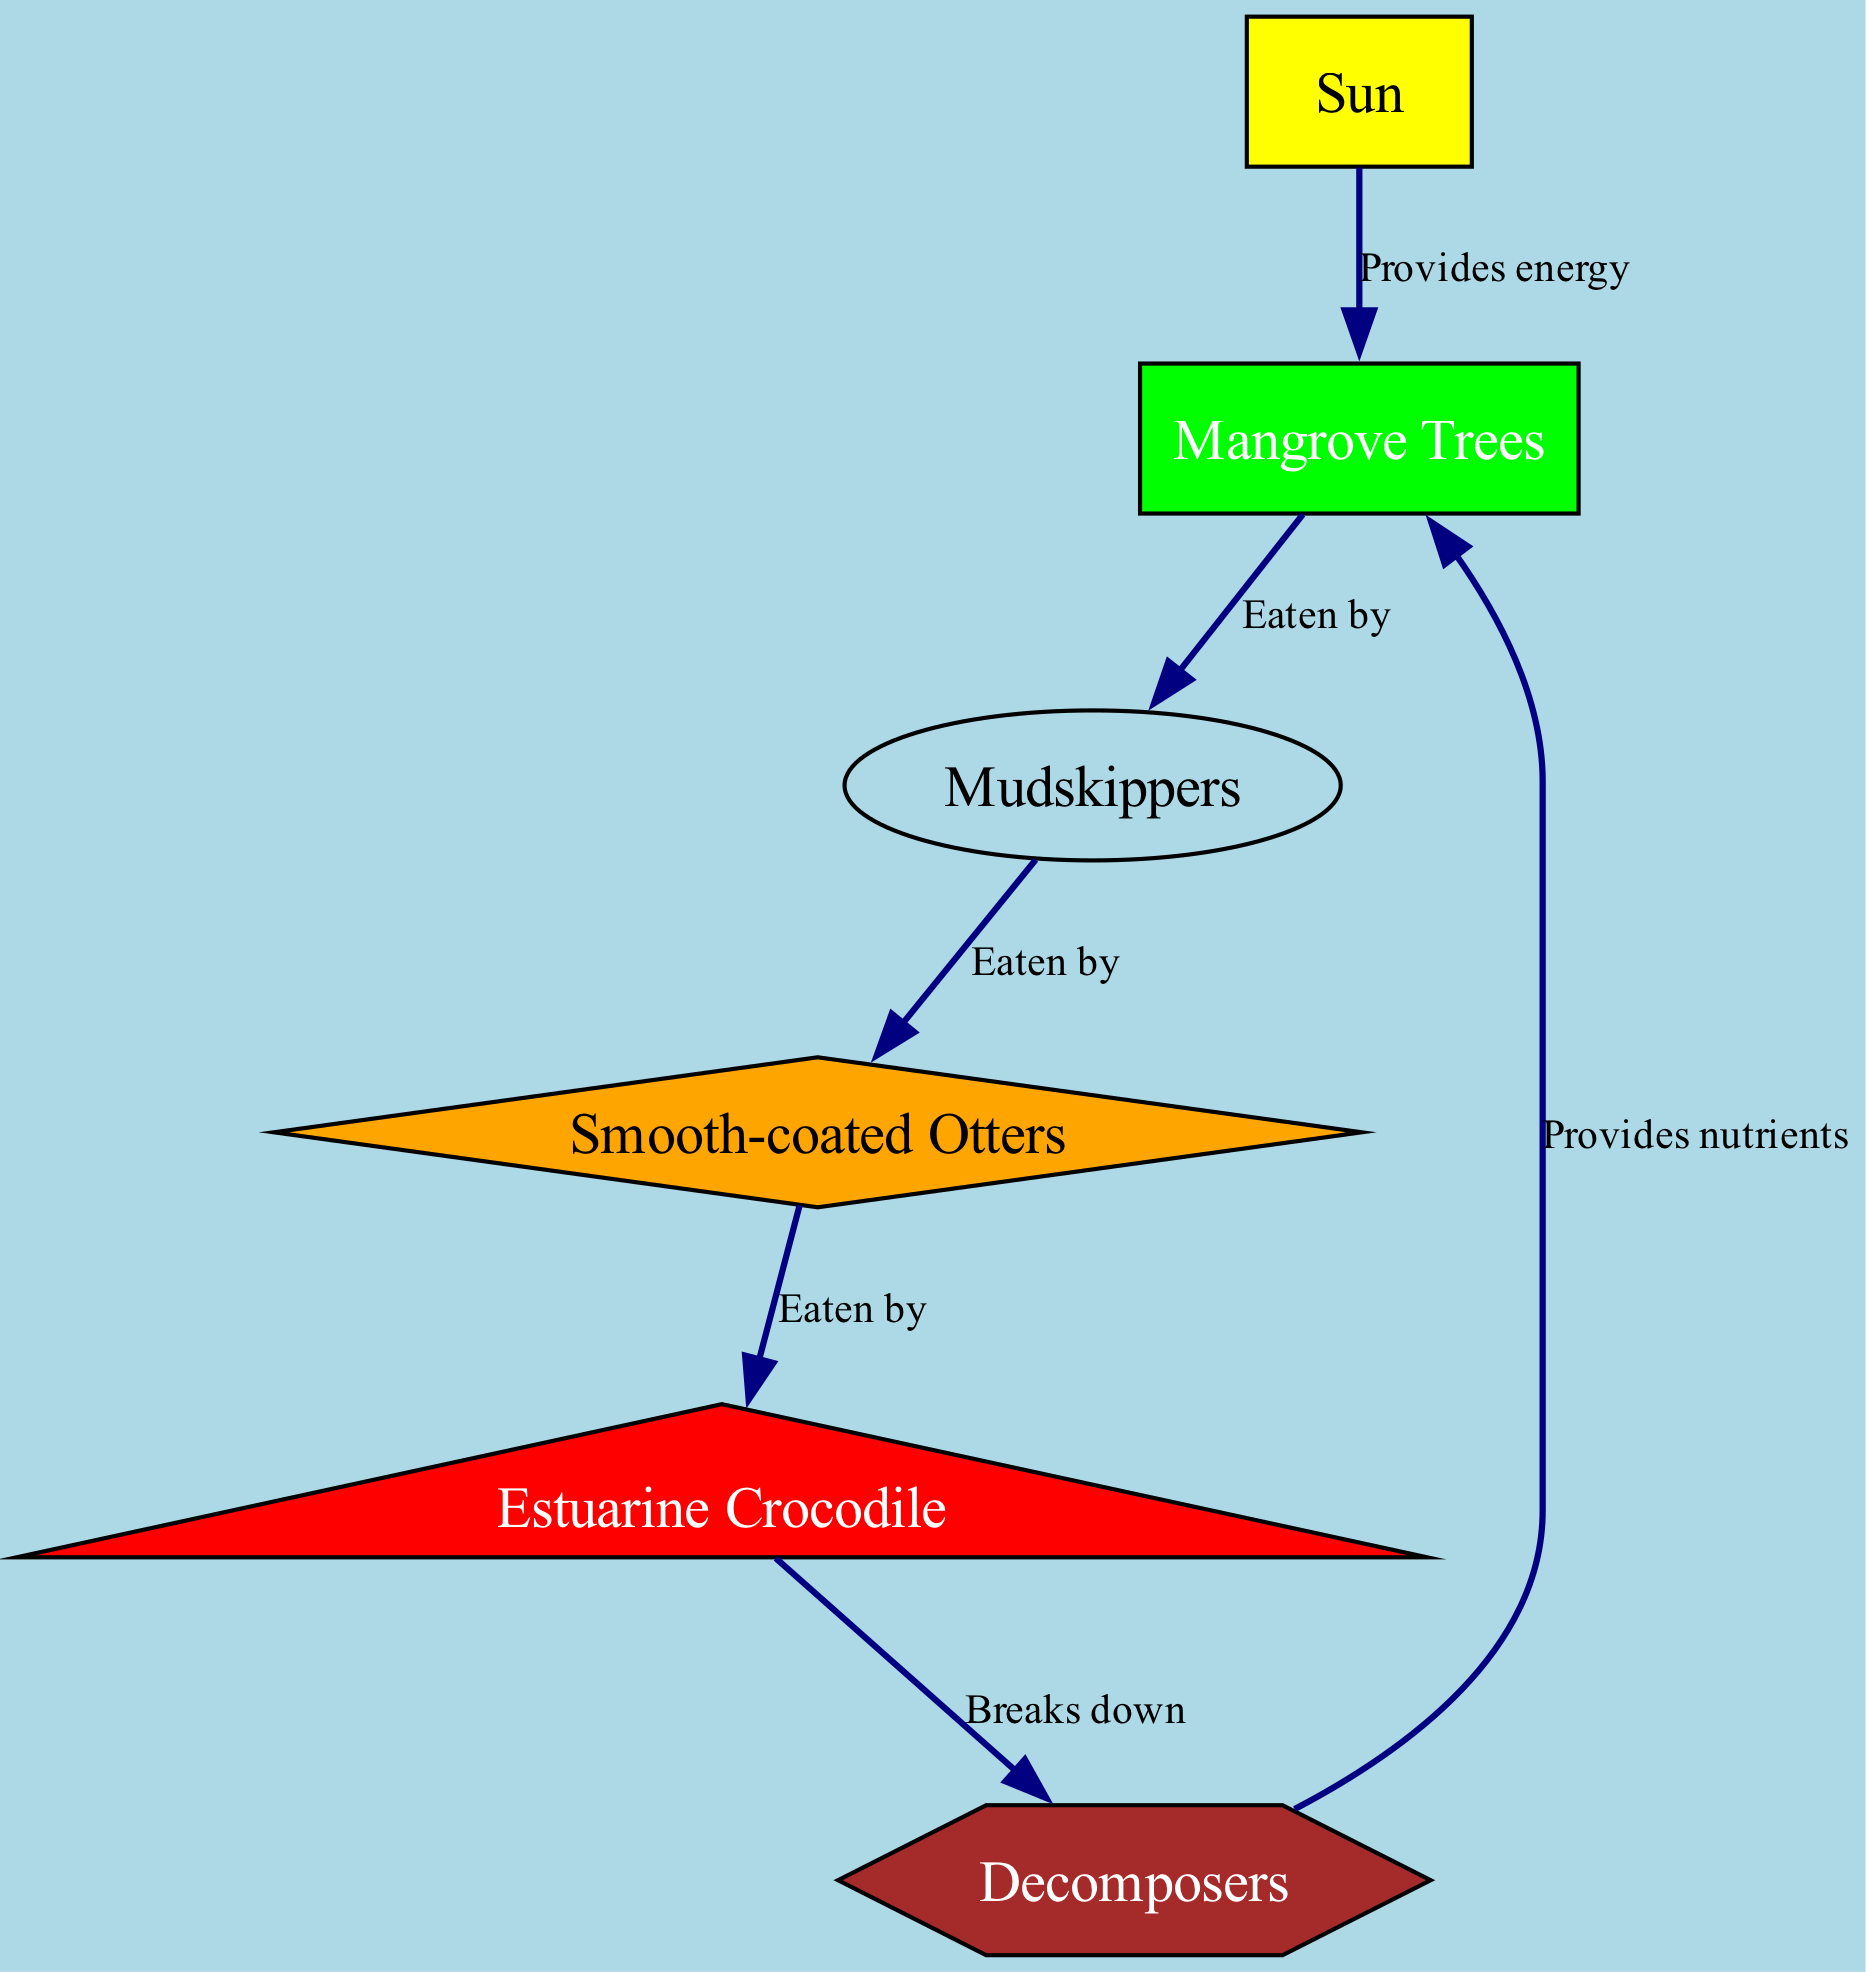What is the primary energy source in this food chain? The first node in the diagram, labeled "Sun," represents the primary energy source that fuels the other organisms in the food chain.
Answer: Sun Which organism is a primary consumer? By examining the node types, "Mudskippers" is identified as a primary consumer in this food chain, as they directly consume the producers, which are mangrove trees.
Answer: Mudskippers How many primary consumers are shown in the diagram? The diagram contains one primary consumer, which is the mudskipper, indicated by the type designation and its relation to the mangrove trees.
Answer: 1 What nutrient do decomposers provide to producers? The relationship between the "Decomposers" and "Mangrove Trees" indicates that decomposers provide nutrients back to the mangrove trees, facilitating their growth.
Answer: Nutrients Which organism is at the top of the food chain? The "Estuarine Crocodile" is positioned as the apex predator in the diagram, as it consumes the secondary consumer, which is the smooth-coated otter.
Answer: Estuarine Crocodile What do smooth-coated otters eat? Looking at the relationships, smooth-coated otters eat "Mudskippers," which is clearly outlined in their direct linkage in the food chain.
Answer: Mudskippers How do decomposers contribute to the ecosystem in this diagram? Decomposers like bacteria and fungi play a crucial role in breaking down organic matter, as seen in their function of providing nutrients back to producers, thus supporting the health of the ecosystem.
Answer: Provides nutrients What color represents producers in the diagram? The node style for producers, represented by "Mangrove Trees," is filled with green color, designating it clearly in the diagram.
Answer: Green Which organism is considered a secondary consumer? Upon reviewing the diagram and the relationships, "Smooth-coated Otters" are classified as secondary consumers because they consume primary consumers (mudskippers).
Answer: Smooth-coated Otters 